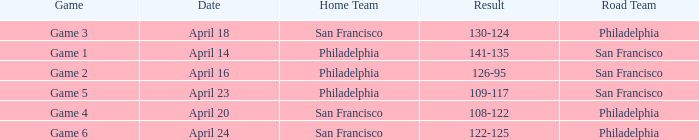On what date was game 2 played? April 16. 